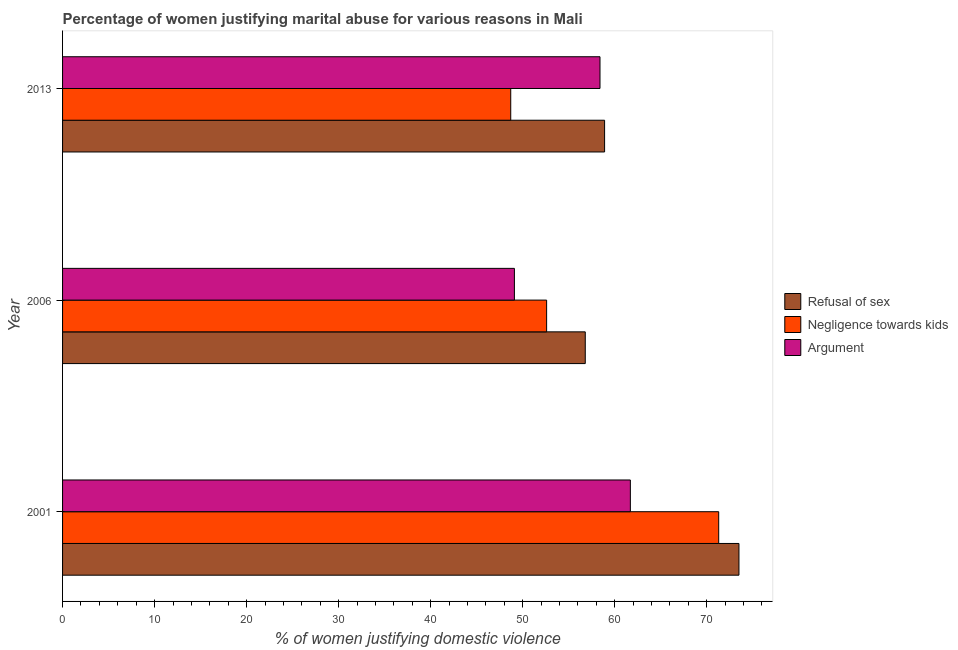How many different coloured bars are there?
Ensure brevity in your answer.  3. Are the number of bars on each tick of the Y-axis equal?
Provide a short and direct response. Yes. How many bars are there on the 1st tick from the bottom?
Make the answer very short. 3. What is the label of the 2nd group of bars from the top?
Your answer should be compact. 2006. In how many cases, is the number of bars for a given year not equal to the number of legend labels?
Your answer should be compact. 0. What is the percentage of women justifying domestic violence due to refusal of sex in 2001?
Ensure brevity in your answer.  73.5. Across all years, what is the maximum percentage of women justifying domestic violence due to negligence towards kids?
Provide a succinct answer. 71.3. Across all years, what is the minimum percentage of women justifying domestic violence due to negligence towards kids?
Give a very brief answer. 48.7. In which year was the percentage of women justifying domestic violence due to negligence towards kids maximum?
Offer a very short reply. 2001. In which year was the percentage of women justifying domestic violence due to negligence towards kids minimum?
Offer a very short reply. 2013. What is the total percentage of women justifying domestic violence due to negligence towards kids in the graph?
Provide a short and direct response. 172.6. What is the average percentage of women justifying domestic violence due to negligence towards kids per year?
Offer a very short reply. 57.53. In the year 2006, what is the difference between the percentage of women justifying domestic violence due to refusal of sex and percentage of women justifying domestic violence due to negligence towards kids?
Ensure brevity in your answer.  4.2. In how many years, is the percentage of women justifying domestic violence due to negligence towards kids greater than 66 %?
Provide a short and direct response. 1. What is the ratio of the percentage of women justifying domestic violence due to refusal of sex in 2001 to that in 2013?
Provide a succinct answer. 1.25. Is the percentage of women justifying domestic violence due to negligence towards kids in 2001 less than that in 2006?
Make the answer very short. No. Is the difference between the percentage of women justifying domestic violence due to refusal of sex in 2001 and 2006 greater than the difference between the percentage of women justifying domestic violence due to arguments in 2001 and 2006?
Ensure brevity in your answer.  Yes. What is the difference between the highest and the second highest percentage of women justifying domestic violence due to arguments?
Your response must be concise. 3.3. What is the difference between the highest and the lowest percentage of women justifying domestic violence due to negligence towards kids?
Offer a terse response. 22.6. What does the 2nd bar from the top in 2006 represents?
Your answer should be very brief. Negligence towards kids. What does the 3rd bar from the bottom in 2013 represents?
Offer a terse response. Argument. Is it the case that in every year, the sum of the percentage of women justifying domestic violence due to refusal of sex and percentage of women justifying domestic violence due to negligence towards kids is greater than the percentage of women justifying domestic violence due to arguments?
Provide a short and direct response. Yes. How many bars are there?
Offer a terse response. 9. How many years are there in the graph?
Make the answer very short. 3. Are the values on the major ticks of X-axis written in scientific E-notation?
Ensure brevity in your answer.  No. Does the graph contain any zero values?
Give a very brief answer. No. Does the graph contain grids?
Offer a very short reply. No. How many legend labels are there?
Ensure brevity in your answer.  3. What is the title of the graph?
Give a very brief answer. Percentage of women justifying marital abuse for various reasons in Mali. Does "Unpaid family workers" appear as one of the legend labels in the graph?
Your answer should be very brief. No. What is the label or title of the X-axis?
Your answer should be compact. % of women justifying domestic violence. What is the % of women justifying domestic violence in Refusal of sex in 2001?
Keep it short and to the point. 73.5. What is the % of women justifying domestic violence of Negligence towards kids in 2001?
Offer a terse response. 71.3. What is the % of women justifying domestic violence of Argument in 2001?
Your answer should be compact. 61.7. What is the % of women justifying domestic violence of Refusal of sex in 2006?
Your answer should be very brief. 56.8. What is the % of women justifying domestic violence in Negligence towards kids in 2006?
Offer a terse response. 52.6. What is the % of women justifying domestic violence of Argument in 2006?
Keep it short and to the point. 49.1. What is the % of women justifying domestic violence of Refusal of sex in 2013?
Your answer should be very brief. 58.9. What is the % of women justifying domestic violence of Negligence towards kids in 2013?
Provide a succinct answer. 48.7. What is the % of women justifying domestic violence of Argument in 2013?
Provide a succinct answer. 58.4. Across all years, what is the maximum % of women justifying domestic violence in Refusal of sex?
Your answer should be very brief. 73.5. Across all years, what is the maximum % of women justifying domestic violence in Negligence towards kids?
Offer a very short reply. 71.3. Across all years, what is the maximum % of women justifying domestic violence in Argument?
Your response must be concise. 61.7. Across all years, what is the minimum % of women justifying domestic violence in Refusal of sex?
Give a very brief answer. 56.8. Across all years, what is the minimum % of women justifying domestic violence in Negligence towards kids?
Provide a succinct answer. 48.7. Across all years, what is the minimum % of women justifying domestic violence in Argument?
Provide a succinct answer. 49.1. What is the total % of women justifying domestic violence in Refusal of sex in the graph?
Your answer should be very brief. 189.2. What is the total % of women justifying domestic violence in Negligence towards kids in the graph?
Provide a short and direct response. 172.6. What is the total % of women justifying domestic violence in Argument in the graph?
Your answer should be very brief. 169.2. What is the difference between the % of women justifying domestic violence of Refusal of sex in 2001 and that in 2006?
Your answer should be very brief. 16.7. What is the difference between the % of women justifying domestic violence of Negligence towards kids in 2001 and that in 2013?
Your answer should be compact. 22.6. What is the difference between the % of women justifying domestic violence in Argument in 2006 and that in 2013?
Offer a terse response. -9.3. What is the difference between the % of women justifying domestic violence of Refusal of sex in 2001 and the % of women justifying domestic violence of Negligence towards kids in 2006?
Offer a very short reply. 20.9. What is the difference between the % of women justifying domestic violence of Refusal of sex in 2001 and the % of women justifying domestic violence of Argument in 2006?
Offer a very short reply. 24.4. What is the difference between the % of women justifying domestic violence in Refusal of sex in 2001 and the % of women justifying domestic violence in Negligence towards kids in 2013?
Your response must be concise. 24.8. What is the difference between the % of women justifying domestic violence of Refusal of sex in 2001 and the % of women justifying domestic violence of Argument in 2013?
Offer a terse response. 15.1. What is the difference between the % of women justifying domestic violence in Refusal of sex in 2006 and the % of women justifying domestic violence in Negligence towards kids in 2013?
Your response must be concise. 8.1. What is the average % of women justifying domestic violence in Refusal of sex per year?
Offer a terse response. 63.07. What is the average % of women justifying domestic violence in Negligence towards kids per year?
Provide a succinct answer. 57.53. What is the average % of women justifying domestic violence in Argument per year?
Your answer should be compact. 56.4. In the year 2001, what is the difference between the % of women justifying domestic violence in Refusal of sex and % of women justifying domestic violence in Argument?
Ensure brevity in your answer.  11.8. In the year 2001, what is the difference between the % of women justifying domestic violence in Negligence towards kids and % of women justifying domestic violence in Argument?
Provide a short and direct response. 9.6. In the year 2006, what is the difference between the % of women justifying domestic violence of Refusal of sex and % of women justifying domestic violence of Negligence towards kids?
Offer a very short reply. 4.2. In the year 2013, what is the difference between the % of women justifying domestic violence of Refusal of sex and % of women justifying domestic violence of Negligence towards kids?
Keep it short and to the point. 10.2. In the year 2013, what is the difference between the % of women justifying domestic violence in Refusal of sex and % of women justifying domestic violence in Argument?
Ensure brevity in your answer.  0.5. What is the ratio of the % of women justifying domestic violence in Refusal of sex in 2001 to that in 2006?
Your answer should be compact. 1.29. What is the ratio of the % of women justifying domestic violence of Negligence towards kids in 2001 to that in 2006?
Your answer should be compact. 1.36. What is the ratio of the % of women justifying domestic violence in Argument in 2001 to that in 2006?
Offer a very short reply. 1.26. What is the ratio of the % of women justifying domestic violence in Refusal of sex in 2001 to that in 2013?
Provide a short and direct response. 1.25. What is the ratio of the % of women justifying domestic violence in Negligence towards kids in 2001 to that in 2013?
Offer a very short reply. 1.46. What is the ratio of the % of women justifying domestic violence in Argument in 2001 to that in 2013?
Make the answer very short. 1.06. What is the ratio of the % of women justifying domestic violence in Refusal of sex in 2006 to that in 2013?
Make the answer very short. 0.96. What is the ratio of the % of women justifying domestic violence in Negligence towards kids in 2006 to that in 2013?
Make the answer very short. 1.08. What is the ratio of the % of women justifying domestic violence of Argument in 2006 to that in 2013?
Your response must be concise. 0.84. What is the difference between the highest and the second highest % of women justifying domestic violence of Argument?
Ensure brevity in your answer.  3.3. What is the difference between the highest and the lowest % of women justifying domestic violence in Negligence towards kids?
Provide a short and direct response. 22.6. What is the difference between the highest and the lowest % of women justifying domestic violence of Argument?
Your response must be concise. 12.6. 